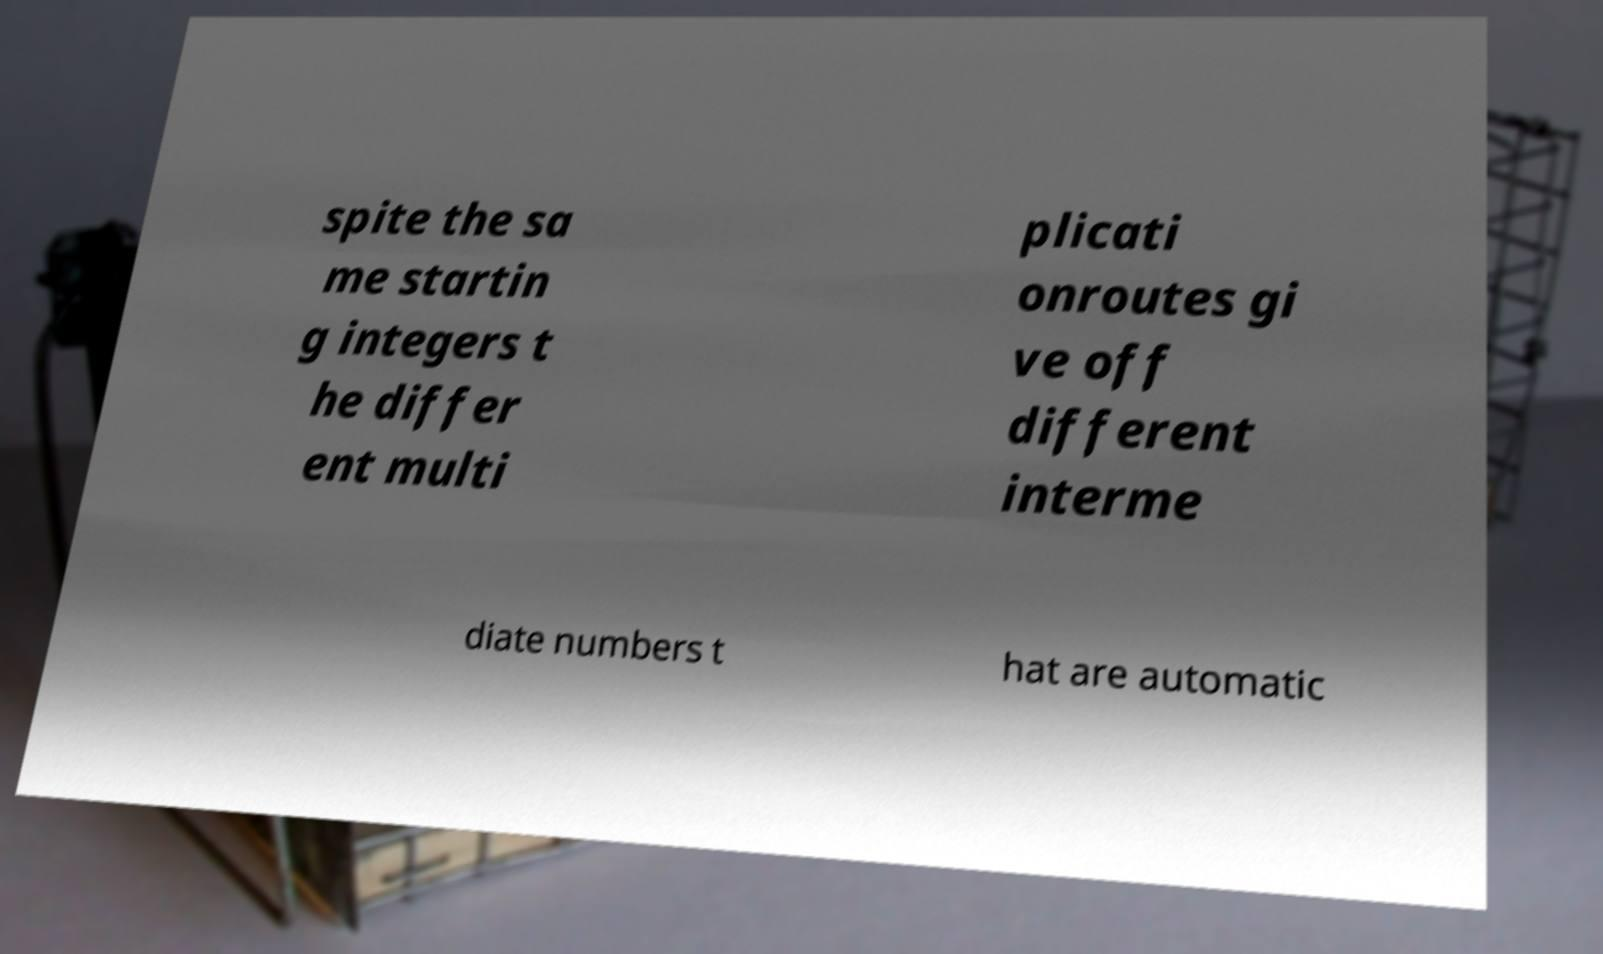What messages or text are displayed in this image? I need them in a readable, typed format. spite the sa me startin g integers t he differ ent multi plicati onroutes gi ve off different interme diate numbers t hat are automatic 